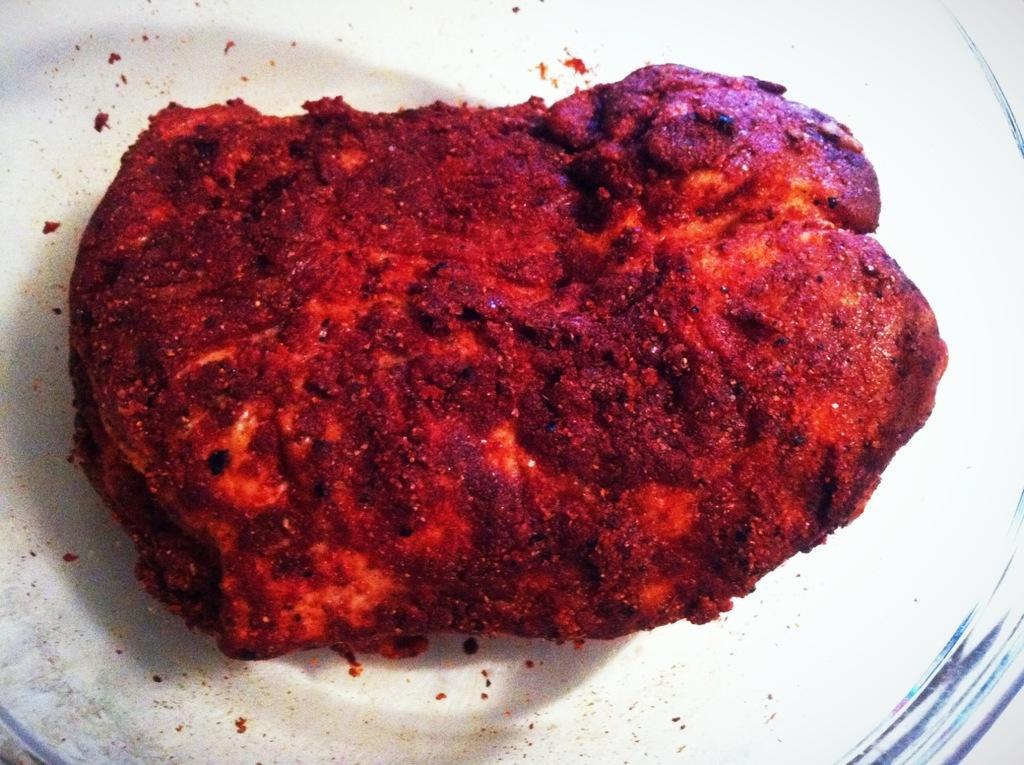Please provide a concise description of this image. In this picture I can observe food. The food is placed in the white color plate. 